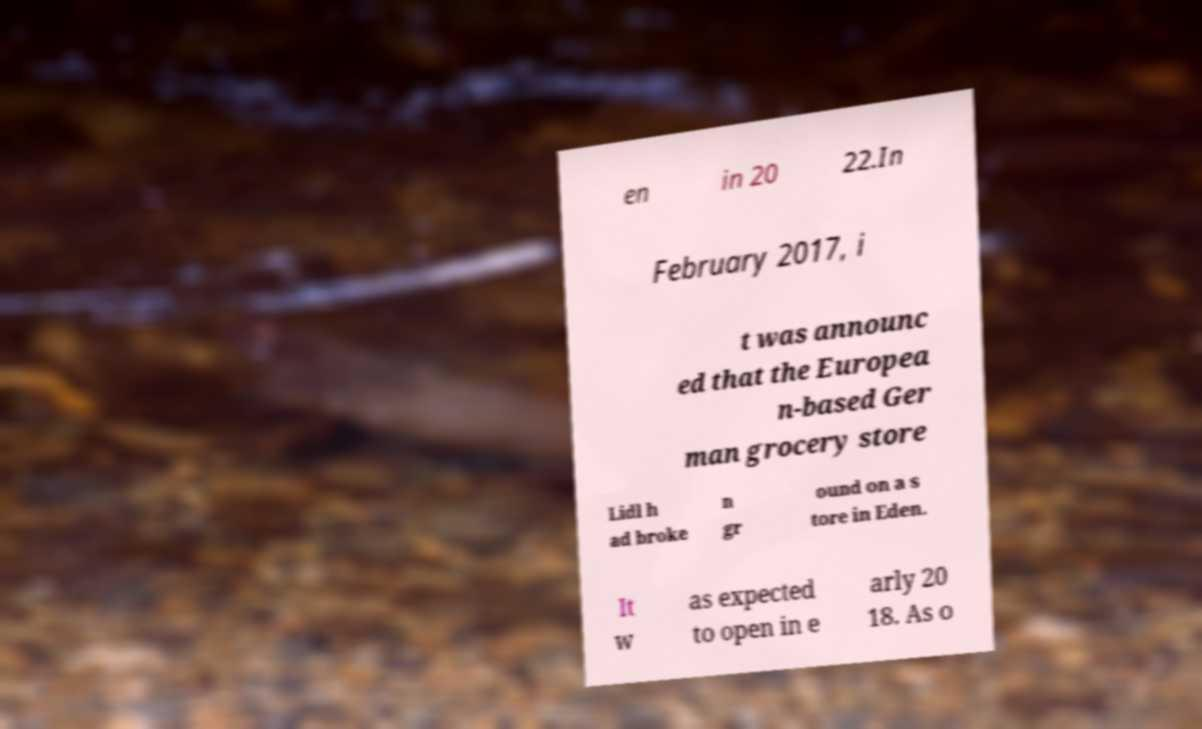Can you read and provide the text displayed in the image?This photo seems to have some interesting text. Can you extract and type it out for me? en in 20 22.In February 2017, i t was announc ed that the Europea n-based Ger man grocery store Lidl h ad broke n gr ound on a s tore in Eden. It w as expected to open in e arly 20 18. As o 